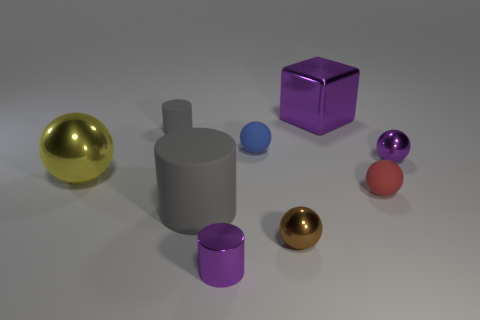Subtract all purple balls. How many balls are left? 4 Subtract all big balls. How many balls are left? 4 Subtract all brown cylinders. Subtract all blue cubes. How many cylinders are left? 3 Subtract all cubes. How many objects are left? 8 Add 6 big cyan metallic cylinders. How many big cyan metallic cylinders exist? 6 Subtract 0 red blocks. How many objects are left? 9 Subtract all small brown metallic cubes. Subtract all tiny shiny cylinders. How many objects are left? 8 Add 7 big shiny blocks. How many big shiny blocks are left? 8 